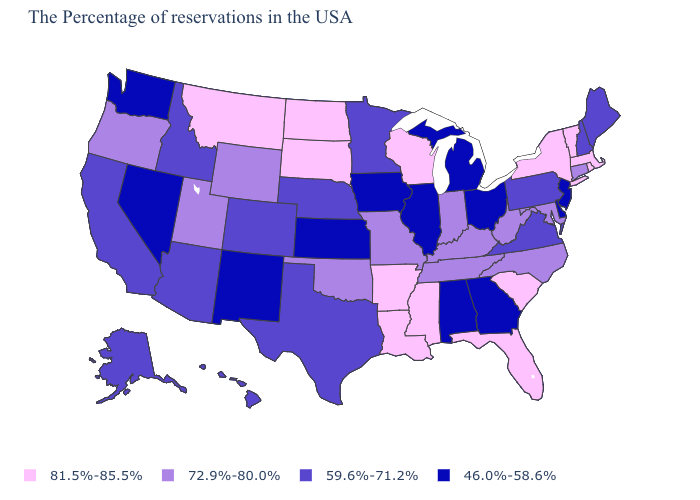Name the states that have a value in the range 81.5%-85.5%?
Quick response, please. Massachusetts, Rhode Island, Vermont, New York, South Carolina, Florida, Wisconsin, Mississippi, Louisiana, Arkansas, South Dakota, North Dakota, Montana. How many symbols are there in the legend?
Concise answer only. 4. Which states have the lowest value in the USA?
Keep it brief. New Jersey, Delaware, Ohio, Georgia, Michigan, Alabama, Illinois, Iowa, Kansas, New Mexico, Nevada, Washington. What is the value of South Dakota?
Keep it brief. 81.5%-85.5%. Among the states that border Connecticut , which have the lowest value?
Short answer required. Massachusetts, Rhode Island, New York. What is the value of Washington?
Give a very brief answer. 46.0%-58.6%. Name the states that have a value in the range 59.6%-71.2%?
Write a very short answer. Maine, New Hampshire, Pennsylvania, Virginia, Minnesota, Nebraska, Texas, Colorado, Arizona, Idaho, California, Alaska, Hawaii. Which states have the lowest value in the South?
Write a very short answer. Delaware, Georgia, Alabama. Which states hav the highest value in the West?
Short answer required. Montana. What is the value of Florida?
Answer briefly. 81.5%-85.5%. What is the lowest value in states that border Idaho?
Be succinct. 46.0%-58.6%. Among the states that border Nebraska , does Colorado have the highest value?
Keep it brief. No. What is the value of New Jersey?
Quick response, please. 46.0%-58.6%. What is the value of Missouri?
Concise answer only. 72.9%-80.0%. 